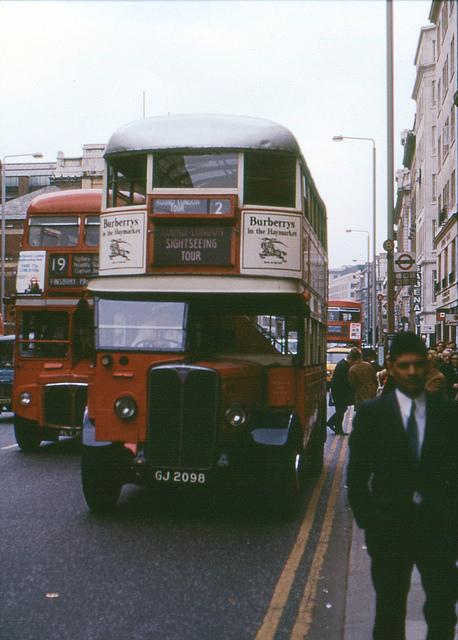How many double decker buses are in this scene?
Concise answer only. 3. What kind of tour is the bus on?
Quick response, please. Sightseeing. Where do you see the letter G?
Keep it brief. License plate. 